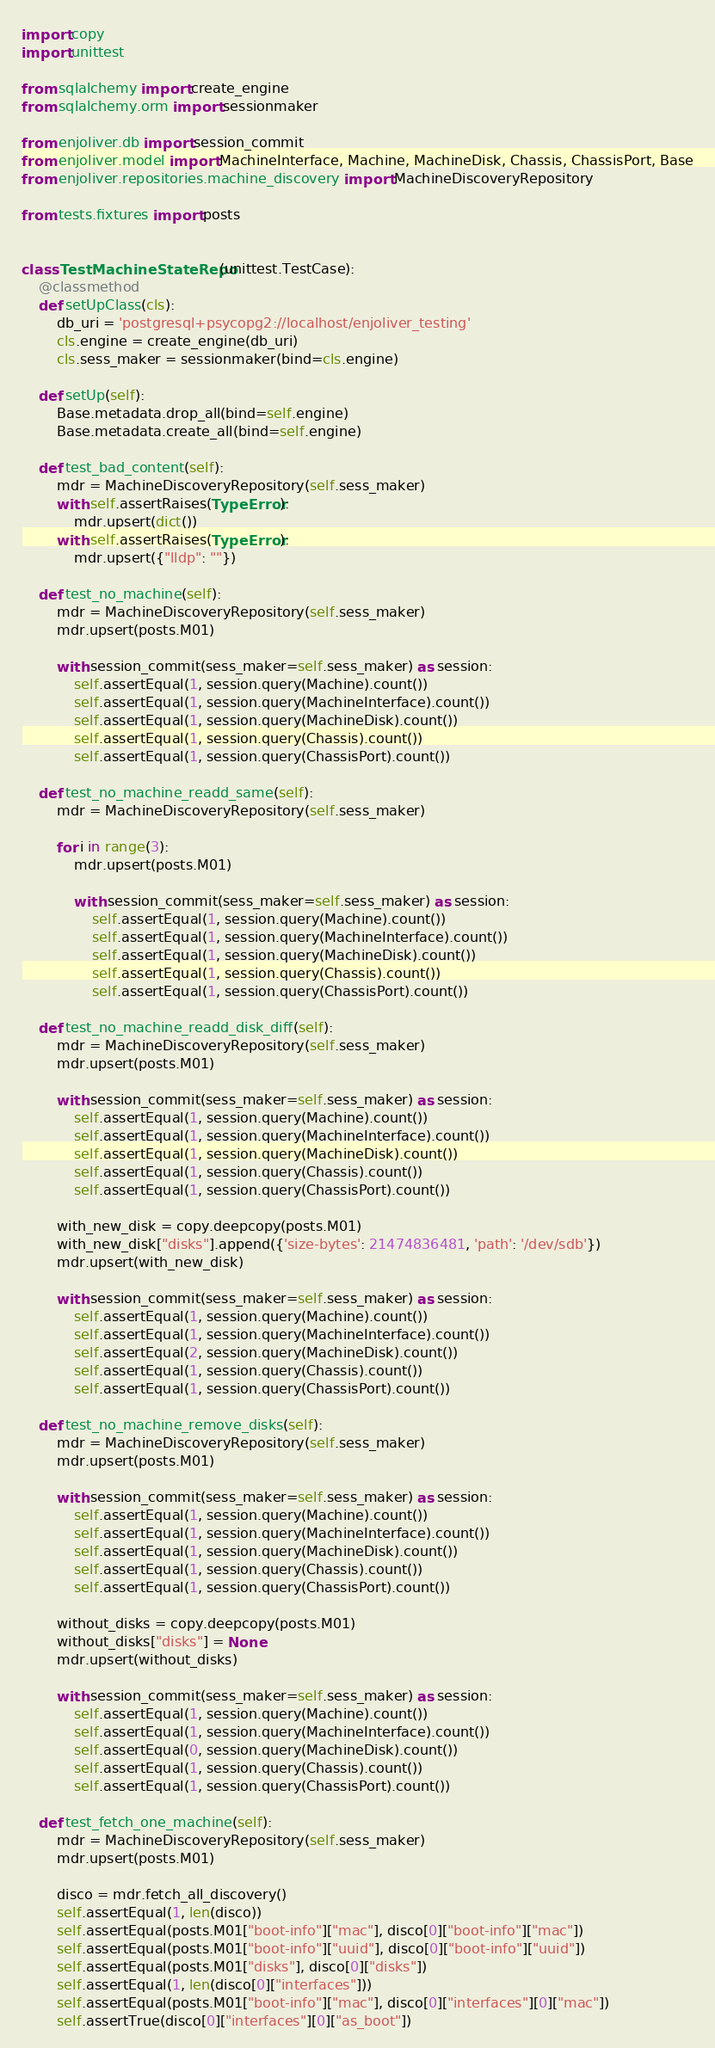Convert code to text. <code><loc_0><loc_0><loc_500><loc_500><_Python_>import copy
import unittest

from sqlalchemy import create_engine
from sqlalchemy.orm import sessionmaker

from enjoliver.db import session_commit
from enjoliver.model import MachineInterface, Machine, MachineDisk, Chassis, ChassisPort, Base
from enjoliver.repositories.machine_discovery import MachineDiscoveryRepository

from tests.fixtures import posts


class TestMachineStateRepo(unittest.TestCase):
    @classmethod
    def setUpClass(cls):
        db_uri = 'postgresql+psycopg2://localhost/enjoliver_testing'
        cls.engine = create_engine(db_uri)
        cls.sess_maker = sessionmaker(bind=cls.engine)

    def setUp(self):
        Base.metadata.drop_all(bind=self.engine)
        Base.metadata.create_all(bind=self.engine)

    def test_bad_content(self):
        mdr = MachineDiscoveryRepository(self.sess_maker)
        with self.assertRaises(TypeError):
            mdr.upsert(dict())
        with self.assertRaises(TypeError):
            mdr.upsert({"lldp": ""})

    def test_no_machine(self):
        mdr = MachineDiscoveryRepository(self.sess_maker)
        mdr.upsert(posts.M01)

        with session_commit(sess_maker=self.sess_maker) as session:
            self.assertEqual(1, session.query(Machine).count())
            self.assertEqual(1, session.query(MachineInterface).count())
            self.assertEqual(1, session.query(MachineDisk).count())
            self.assertEqual(1, session.query(Chassis).count())
            self.assertEqual(1, session.query(ChassisPort).count())

    def test_no_machine_readd_same(self):
        mdr = MachineDiscoveryRepository(self.sess_maker)

        for i in range(3):
            mdr.upsert(posts.M01)

            with session_commit(sess_maker=self.sess_maker) as session:
                self.assertEqual(1, session.query(Machine).count())
                self.assertEqual(1, session.query(MachineInterface).count())
                self.assertEqual(1, session.query(MachineDisk).count())
                self.assertEqual(1, session.query(Chassis).count())
                self.assertEqual(1, session.query(ChassisPort).count())

    def test_no_machine_readd_disk_diff(self):
        mdr = MachineDiscoveryRepository(self.sess_maker)
        mdr.upsert(posts.M01)

        with session_commit(sess_maker=self.sess_maker) as session:
            self.assertEqual(1, session.query(Machine).count())
            self.assertEqual(1, session.query(MachineInterface).count())
            self.assertEqual(1, session.query(MachineDisk).count())
            self.assertEqual(1, session.query(Chassis).count())
            self.assertEqual(1, session.query(ChassisPort).count())

        with_new_disk = copy.deepcopy(posts.M01)
        with_new_disk["disks"].append({'size-bytes': 21474836481, 'path': '/dev/sdb'})
        mdr.upsert(with_new_disk)

        with session_commit(sess_maker=self.sess_maker) as session:
            self.assertEqual(1, session.query(Machine).count())
            self.assertEqual(1, session.query(MachineInterface).count())
            self.assertEqual(2, session.query(MachineDisk).count())
            self.assertEqual(1, session.query(Chassis).count())
            self.assertEqual(1, session.query(ChassisPort).count())

    def test_no_machine_remove_disks(self):
        mdr = MachineDiscoveryRepository(self.sess_maker)
        mdr.upsert(posts.M01)

        with session_commit(sess_maker=self.sess_maker) as session:
            self.assertEqual(1, session.query(Machine).count())
            self.assertEqual(1, session.query(MachineInterface).count())
            self.assertEqual(1, session.query(MachineDisk).count())
            self.assertEqual(1, session.query(Chassis).count())
            self.assertEqual(1, session.query(ChassisPort).count())

        without_disks = copy.deepcopy(posts.M01)
        without_disks["disks"] = None
        mdr.upsert(without_disks)

        with session_commit(sess_maker=self.sess_maker) as session:
            self.assertEqual(1, session.query(Machine).count())
            self.assertEqual(1, session.query(MachineInterface).count())
            self.assertEqual(0, session.query(MachineDisk).count())
            self.assertEqual(1, session.query(Chassis).count())
            self.assertEqual(1, session.query(ChassisPort).count())

    def test_fetch_one_machine(self):
        mdr = MachineDiscoveryRepository(self.sess_maker)
        mdr.upsert(posts.M01)

        disco = mdr.fetch_all_discovery()
        self.assertEqual(1, len(disco))
        self.assertEqual(posts.M01["boot-info"]["mac"], disco[0]["boot-info"]["mac"])
        self.assertEqual(posts.M01["boot-info"]["uuid"], disco[0]["boot-info"]["uuid"])
        self.assertEqual(posts.M01["disks"], disco[0]["disks"])
        self.assertEqual(1, len(disco[0]["interfaces"]))
        self.assertEqual(posts.M01["boot-info"]["mac"], disco[0]["interfaces"][0]["mac"])
        self.assertTrue(disco[0]["interfaces"][0]["as_boot"])
</code> 